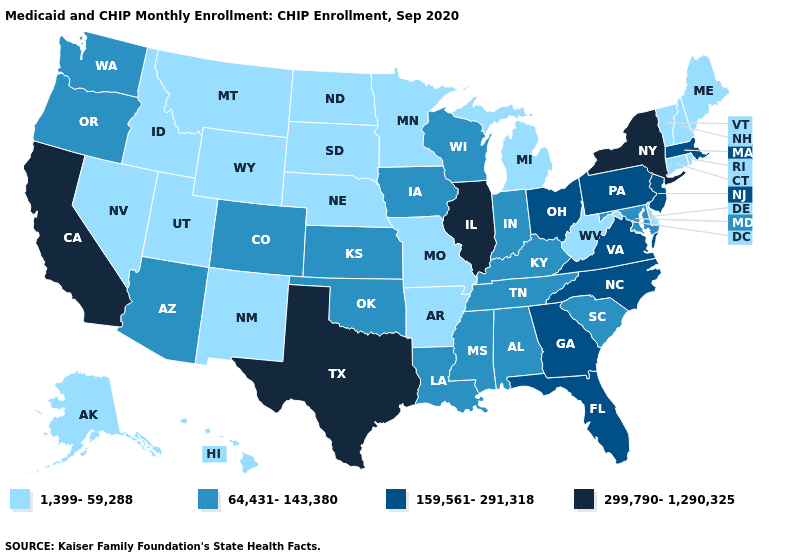What is the highest value in the USA?
Be succinct. 299,790-1,290,325. What is the value of California?
Answer briefly. 299,790-1,290,325. Name the states that have a value in the range 159,561-291,318?
Answer briefly. Florida, Georgia, Massachusetts, New Jersey, North Carolina, Ohio, Pennsylvania, Virginia. What is the lowest value in the MidWest?
Concise answer only. 1,399-59,288. Among the states that border Montana , which have the highest value?
Give a very brief answer. Idaho, North Dakota, South Dakota, Wyoming. Does West Virginia have a lower value than Alaska?
Give a very brief answer. No. Name the states that have a value in the range 64,431-143,380?
Short answer required. Alabama, Arizona, Colorado, Indiana, Iowa, Kansas, Kentucky, Louisiana, Maryland, Mississippi, Oklahoma, Oregon, South Carolina, Tennessee, Washington, Wisconsin. What is the lowest value in the South?
Give a very brief answer. 1,399-59,288. What is the value of Ohio?
Be succinct. 159,561-291,318. Does North Carolina have the same value as Massachusetts?
Answer briefly. Yes. Among the states that border New Jersey , does Delaware have the lowest value?
Give a very brief answer. Yes. Does Illinois have the highest value in the USA?
Short answer required. Yes. Does Vermont have the highest value in the Northeast?
Keep it brief. No. Is the legend a continuous bar?
Keep it brief. No. What is the value of Vermont?
Keep it brief. 1,399-59,288. 